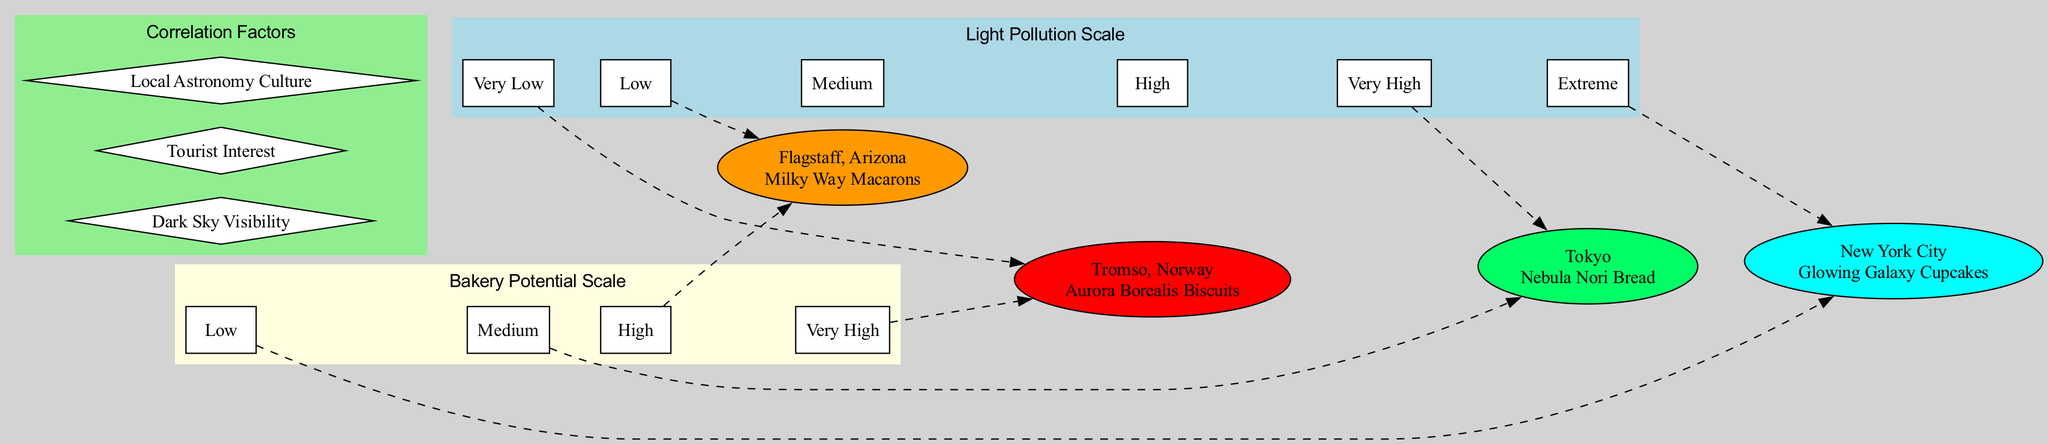What is the light pollution level in Tromso, Norway? The diagram indicates that Tromso, Norway is characterized by "Very Low" light pollution based on the light pollution scale represented.
Answer: Very Low Which city has the highest bakery potential? By examining the bakery potential scale, Tromso, Norway is marked as having "Very High" bakery potential, which is the highest level on the scale.
Answer: Very High How many correlation factors are shown in the diagram? A count of the nodes in the correlation factors subgraph indicates there are three distinct factors displayed, confirming that there are three correlation factors in total.
Answer: 3 What is the specialty of the bakery in Flagstaff, Arizona? The diagram states that Flagstaff, Arizona's bakery specialty is "Milky Way Macarons," which is specifically mentioned in the information about that city.
Answer: Milky Way Macarons What is the relationship between low light pollution and bakery potential in Tromso? The diagram illustrates that Tromso has "Very Low" light pollution combined with "Very High" bakery potential, suggesting a positive correlation for stargazing-themed bakeries in darker areas.
Answer: Positive correlation 